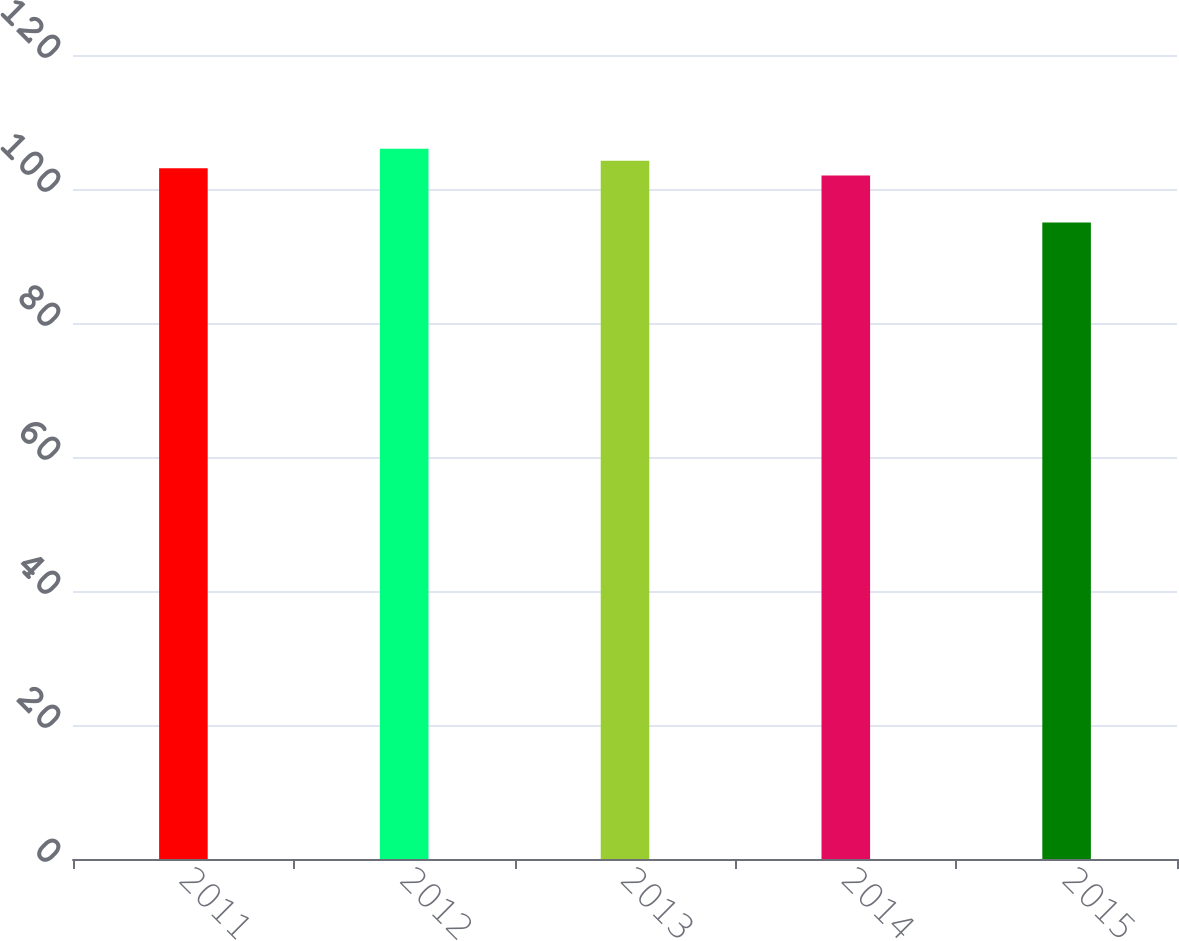Convert chart. <chart><loc_0><loc_0><loc_500><loc_500><bar_chart><fcel>2011<fcel>2012<fcel>2013<fcel>2014<fcel>2015<nl><fcel>103.1<fcel>106<fcel>104.2<fcel>102<fcel>95<nl></chart> 